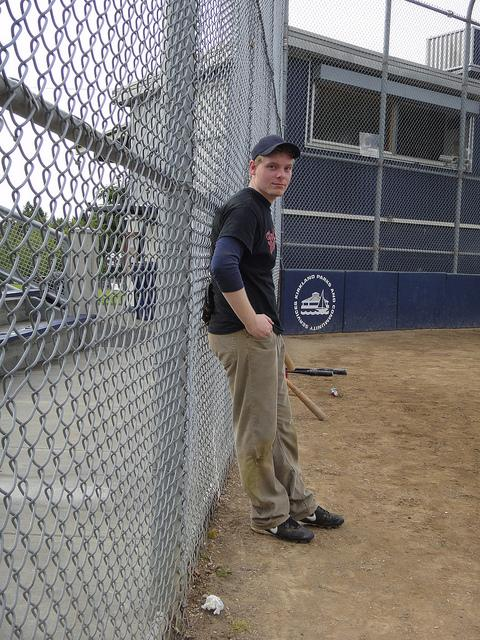What is he doing? leaning 